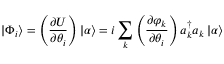Convert formula to latex. <formula><loc_0><loc_0><loc_500><loc_500>| \Phi _ { i } \rangle = \left ( \frac { \partial U } { \partial \theta _ { i } } \right ) | \alpha \rangle = i \sum _ { k } \left ( \frac { \partial \varphi _ { k } } { \partial \theta _ { i } } \right ) a _ { k } ^ { \dagger } a _ { k } \, | \alpha \rangle</formula> 